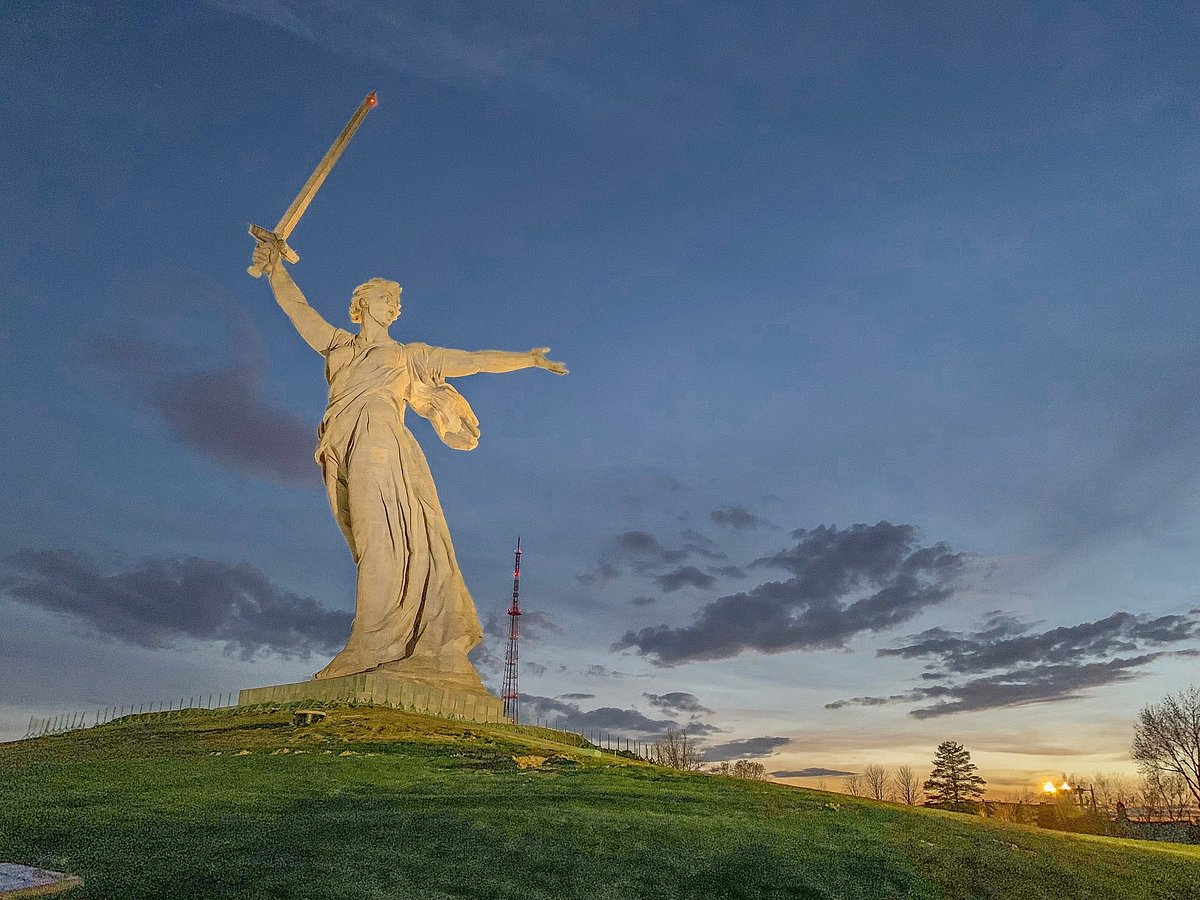Describe a realistic event that could take place in this setting. A realistic event that could take place in this setting would be a commemorative ceremony honoring the Battle of Stalingrad. Veterans, dignitaries, and citizens gather around the base of the statue in solemn remembrance. Speeches recounting the bravery and sacrifices made during the battle fill the air, while a military band plays stirring patriotic music. The setting sun casts a warm glow over the proceedings, evoking a sense of reverence and unity. The ceremony concludes with a flyover by military aircraft, leaving trails of smoke in the colors of the national flag, as the crowd stands in silent tribute to those who fought and fell. 